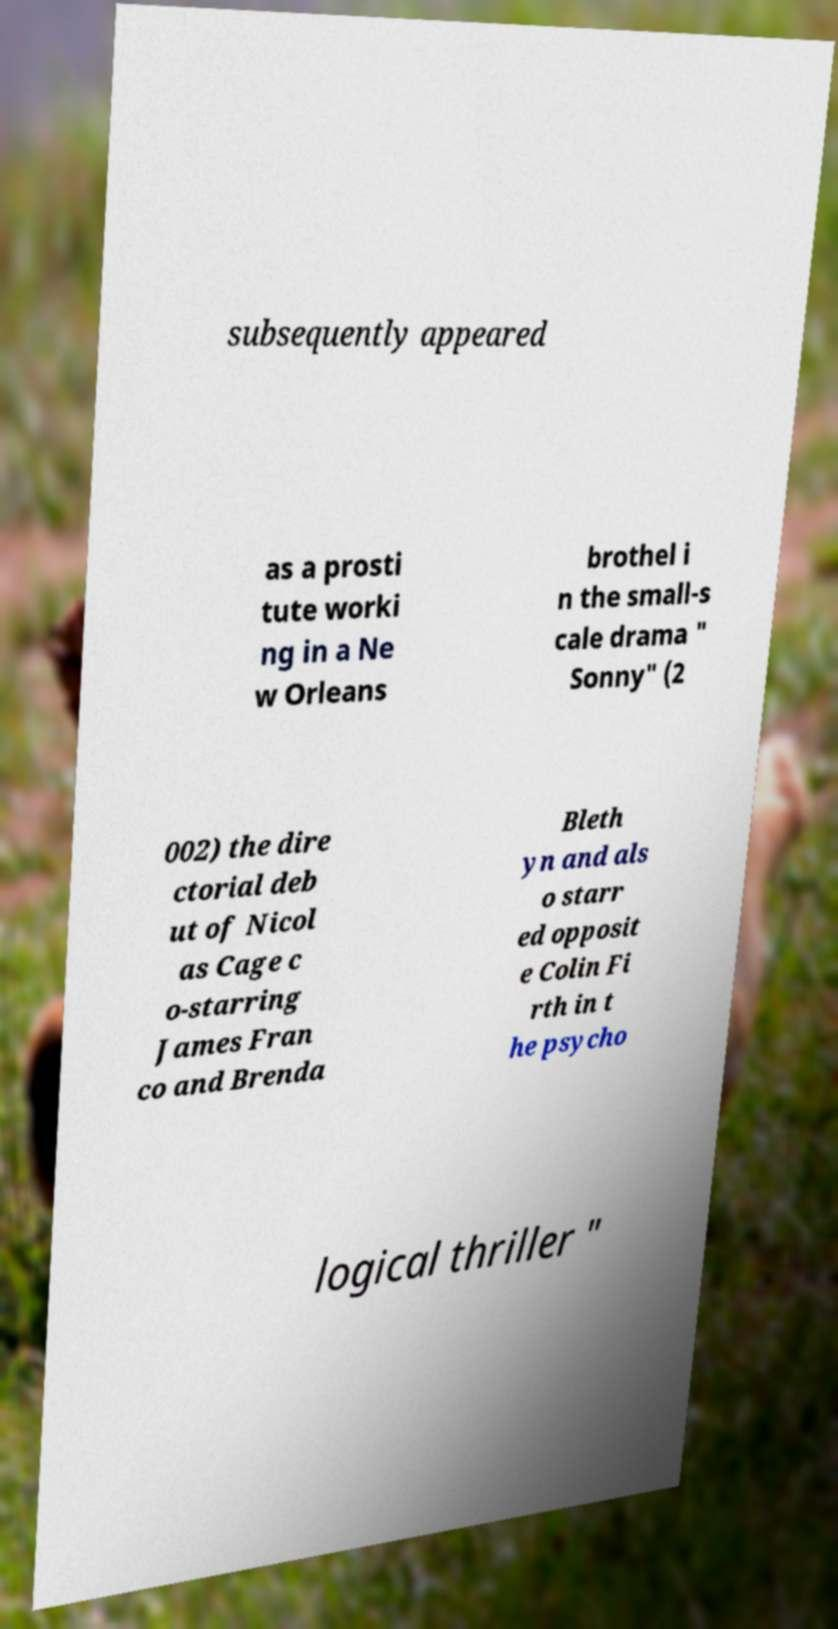Could you assist in decoding the text presented in this image and type it out clearly? subsequently appeared as a prosti tute worki ng in a Ne w Orleans brothel i n the small-s cale drama " Sonny" (2 002) the dire ctorial deb ut of Nicol as Cage c o-starring James Fran co and Brenda Bleth yn and als o starr ed opposit e Colin Fi rth in t he psycho logical thriller " 